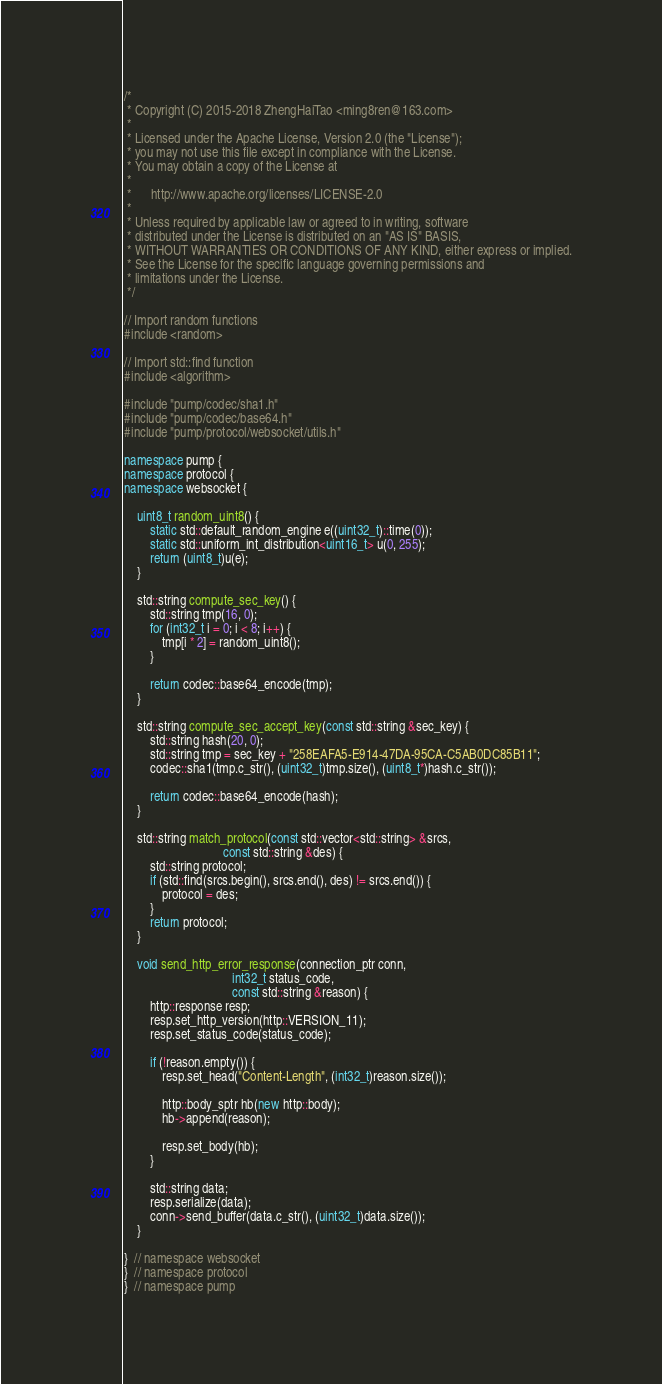<code> <loc_0><loc_0><loc_500><loc_500><_C++_>/*
 * Copyright (C) 2015-2018 ZhengHaiTao <ming8ren@163.com>
 *
 * Licensed under the Apache License, Version 2.0 (the "License");
 * you may not use this file except in compliance with the License.
 * You may obtain a copy of the License at
 *
 *      http://www.apache.org/licenses/LICENSE-2.0
 *
 * Unless required by applicable law or agreed to in writing, software
 * distributed under the License is distributed on an "AS IS" BASIS,
 * WITHOUT WARRANTIES OR CONDITIONS OF ANY KIND, either express or implied.
 * See the License for the specific language governing permissions and
 * limitations under the License.
 */

// Import random functions
#include <random>

// Import std::find function
#include <algorithm>

#include "pump/codec/sha1.h"
#include "pump/codec/base64.h"
#include "pump/protocol/websocket/utils.h"

namespace pump {
namespace protocol {
namespace websocket {

    uint8_t random_uint8() {
        static std::default_random_engine e((uint32_t)::time(0));
        static std::uniform_int_distribution<uint16_t> u(0, 255);
        return (uint8_t)u(e);
    }

    std::string compute_sec_key() {
        std::string tmp(16, 0);
        for (int32_t i = 0; i < 8; i++) {
            tmp[i * 2] = random_uint8();
        }

        return codec::base64_encode(tmp);
    }

    std::string compute_sec_accept_key(const std::string &sec_key) {
        std::string hash(20, 0);
        std::string tmp = sec_key + "258EAFA5-E914-47DA-95CA-C5AB0DC85B11";
        codec::sha1(tmp.c_str(), (uint32_t)tmp.size(), (uint8_t*)hash.c_str());

        return codec::base64_encode(hash);
    }

    std::string match_protocol(const std::vector<std::string> &srcs,
                               const std::string &des) {
        std::string protocol;
        if (std::find(srcs.begin(), srcs.end(), des) != srcs.end()) {
            protocol = des;
        }
        return protocol;
    }

    void send_http_error_response(connection_ptr conn,
                                  int32_t status_code,
                                  const std::string &reason) {
        http::response resp;
        resp.set_http_version(http::VERSION_11);
        resp.set_status_code(status_code);

        if (!reason.empty()) {
            resp.set_head("Content-Length", (int32_t)reason.size());

            http::body_sptr hb(new http::body);
            hb->append(reason);

            resp.set_body(hb);
        }

        std::string data;
        resp.serialize(data);
        conn->send_buffer(data.c_str(), (uint32_t)data.size());
    }

}  // namespace websocket
}  // namespace protocol
}  // namespace pump
</code> 